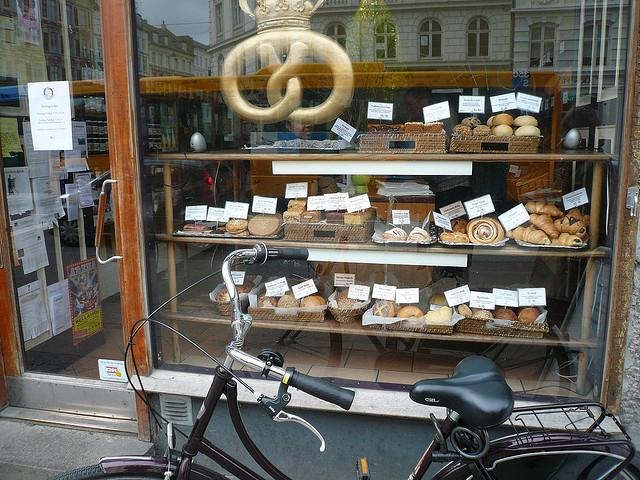What color is painted on the metal frame of the bicycle parked in front of the cake store?

Choices:
A) black
B) red
C) pink
D) green black 